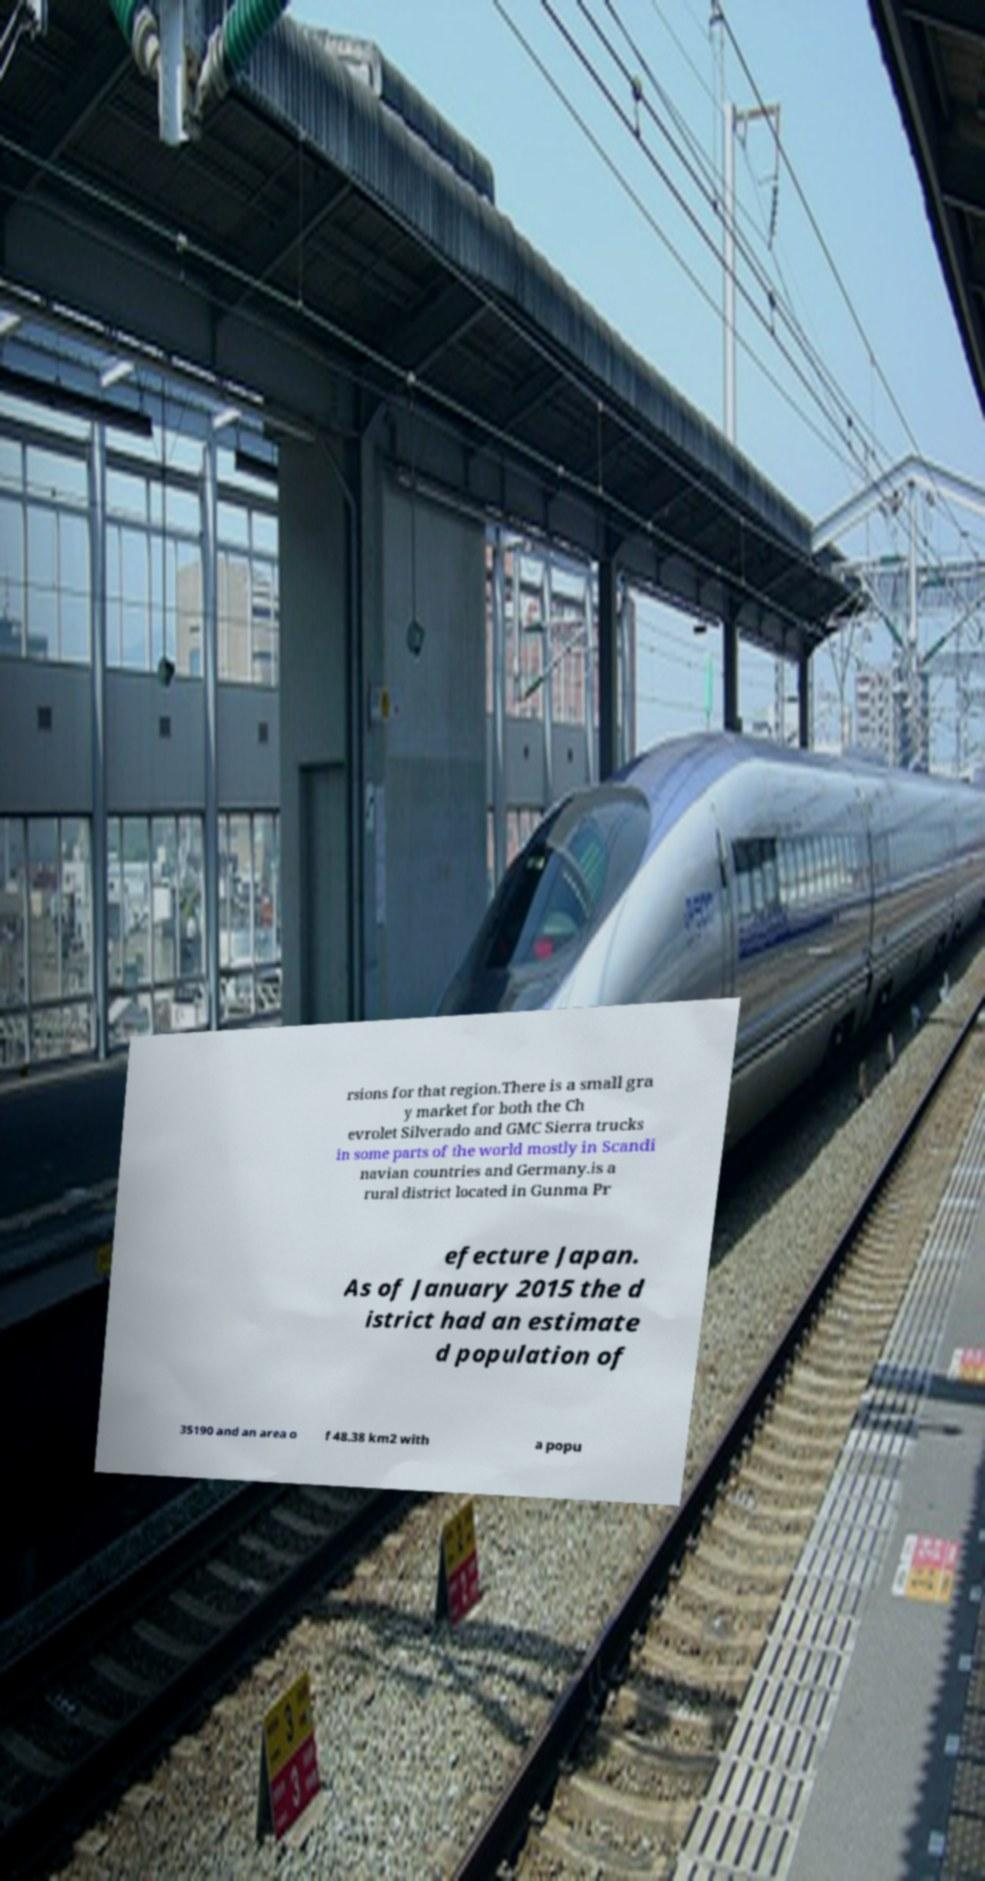Could you extract and type out the text from this image? rsions for that region.There is a small gra y market for both the Ch evrolet Silverado and GMC Sierra trucks in some parts of the world mostly in Scandi navian countries and Germany.is a rural district located in Gunma Pr efecture Japan. As of January 2015 the d istrict had an estimate d population of 35190 and an area o f 48.38 km2 with a popu 